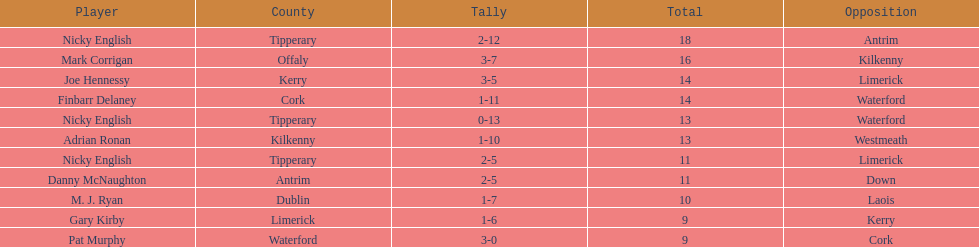Which player ranked the most? Nicky English. 